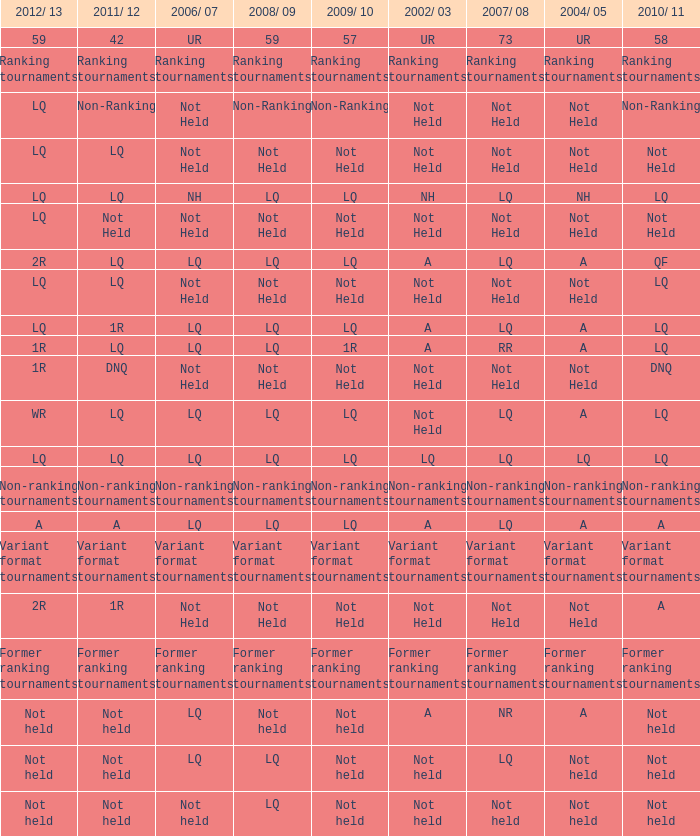Write the full table. {'header': ['2012/ 13', '2011/ 12', '2006/ 07', '2008/ 09', '2009/ 10', '2002/ 03', '2007/ 08', '2004/ 05', '2010/ 11'], 'rows': [['59', '42', 'UR', '59', '57', 'UR', '73', 'UR', '58'], ['Ranking tournaments', 'Ranking tournaments', 'Ranking tournaments', 'Ranking tournaments', 'Ranking tournaments', 'Ranking tournaments', 'Ranking tournaments', 'Ranking tournaments', 'Ranking tournaments'], ['LQ', 'Non-Ranking', 'Not Held', 'Non-Ranking', 'Non-Ranking', 'Not Held', 'Not Held', 'Not Held', 'Non-Ranking'], ['LQ', 'LQ', 'Not Held', 'Not Held', 'Not Held', 'Not Held', 'Not Held', 'Not Held', 'Not Held'], ['LQ', 'LQ', 'NH', 'LQ', 'LQ', 'NH', 'LQ', 'NH', 'LQ'], ['LQ', 'Not Held', 'Not Held', 'Not Held', 'Not Held', 'Not Held', 'Not Held', 'Not Held', 'Not Held'], ['2R', 'LQ', 'LQ', 'LQ', 'LQ', 'A', 'LQ', 'A', 'QF'], ['LQ', 'LQ', 'Not Held', 'Not Held', 'Not Held', 'Not Held', 'Not Held', 'Not Held', 'LQ'], ['LQ', '1R', 'LQ', 'LQ', 'LQ', 'A', 'LQ', 'A', 'LQ'], ['1R', 'LQ', 'LQ', 'LQ', '1R', 'A', 'RR', 'A', 'LQ'], ['1R', 'DNQ', 'Not Held', 'Not Held', 'Not Held', 'Not Held', 'Not Held', 'Not Held', 'DNQ'], ['WR', 'LQ', 'LQ', 'LQ', 'LQ', 'Not Held', 'LQ', 'A', 'LQ'], ['LQ', 'LQ', 'LQ', 'LQ', 'LQ', 'LQ', 'LQ', 'LQ', 'LQ'], ['Non-ranking tournaments', 'Non-ranking tournaments', 'Non-ranking tournaments', 'Non-ranking tournaments', 'Non-ranking tournaments', 'Non-ranking tournaments', 'Non-ranking tournaments', 'Non-ranking tournaments', 'Non-ranking tournaments'], ['A', 'A', 'LQ', 'LQ', 'LQ', 'A', 'LQ', 'A', 'A'], ['Variant format tournaments', 'Variant format tournaments', 'Variant format tournaments', 'Variant format tournaments', 'Variant format tournaments', 'Variant format tournaments', 'Variant format tournaments', 'Variant format tournaments', 'Variant format tournaments'], ['2R', '1R', 'Not Held', 'Not Held', 'Not Held', 'Not Held', 'Not Held', 'Not Held', 'A'], ['Former ranking tournaments', 'Former ranking tournaments', 'Former ranking tournaments', 'Former ranking tournaments', 'Former ranking tournaments', 'Former ranking tournaments', 'Former ranking tournaments', 'Former ranking tournaments', 'Former ranking tournaments'], ['Not held', 'Not held', 'LQ', 'Not held', 'Not held', 'A', 'NR', 'A', 'Not held'], ['Not held', 'Not held', 'LQ', 'LQ', 'Not held', 'Not held', 'LQ', 'Not held', 'Not held'], ['Not held', 'Not held', 'Not held', 'LQ', 'Not held', 'Not held', 'Not held', 'Not held', 'Not held']]} Name the 2009/10 with 2011/12 of a LQ. 